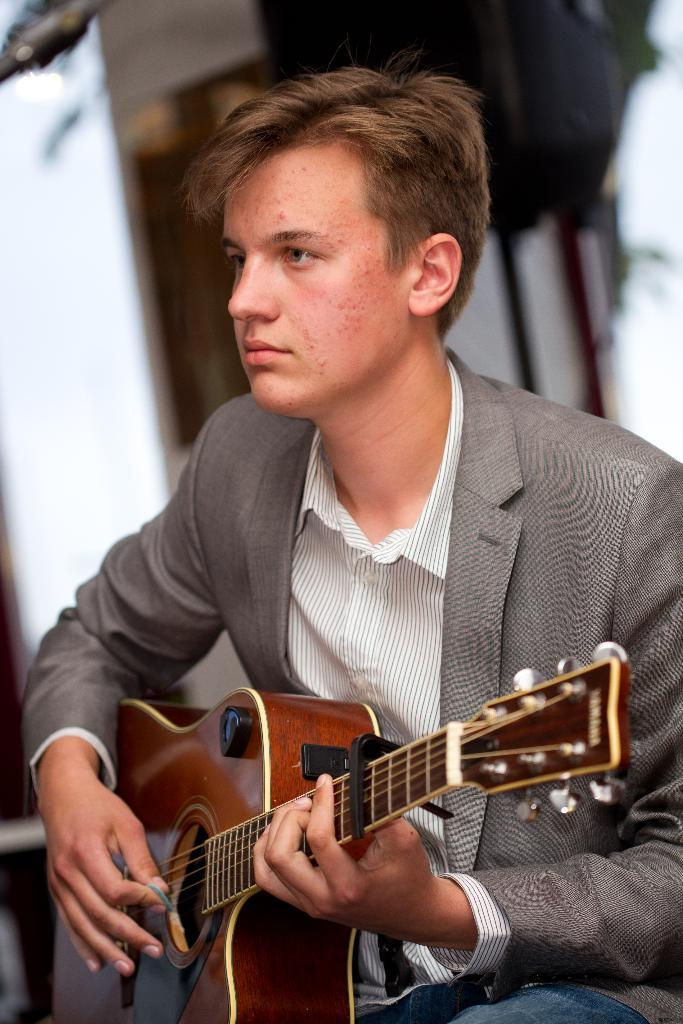Who is the main subject in the image? There is a boy in the image. What is the boy wearing? The boy is wearing a suit. What activity is the boy engaged in? The boy is playing a guitar. What can be seen in the background of the image? There is a wall in the background of the image. How many cows are visible in the image? There are no cows present in the image. What type of fan is being used by the boy in the image? There is no fan visible in the image; the boy is playing a guitar. 